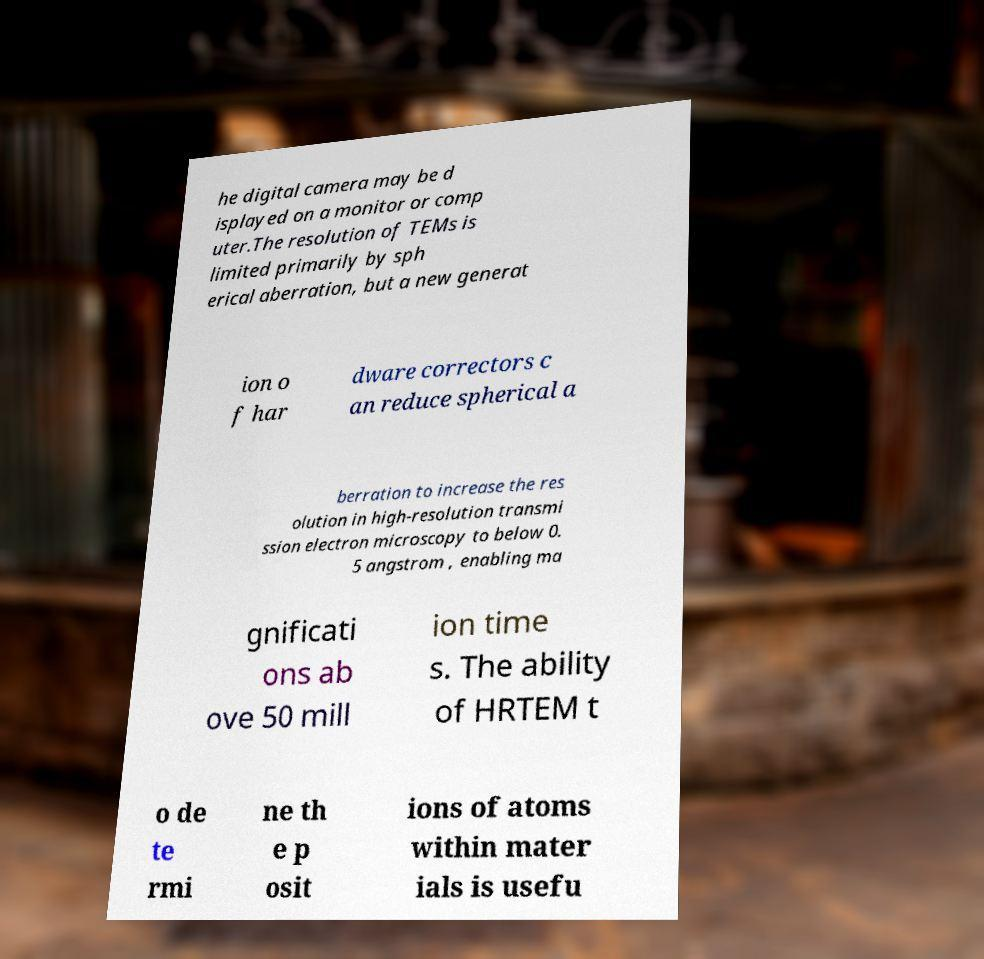Can you accurately transcribe the text from the provided image for me? he digital camera may be d isplayed on a monitor or comp uter.The resolution of TEMs is limited primarily by sph erical aberration, but a new generat ion o f har dware correctors c an reduce spherical a berration to increase the res olution in high-resolution transmi ssion electron microscopy to below 0. 5 angstrom , enabling ma gnificati ons ab ove 50 mill ion time s. The ability of HRTEM t o de te rmi ne th e p osit ions of atoms within mater ials is usefu 